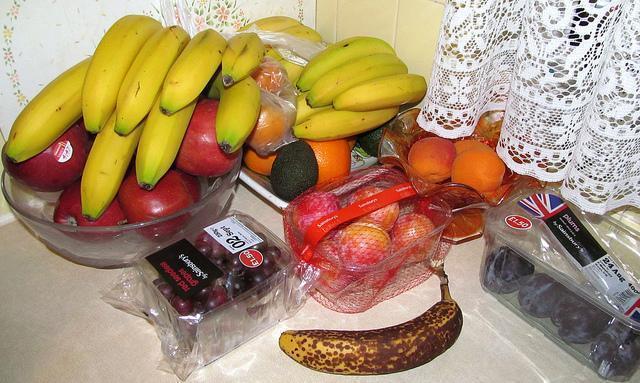What color is the banana without a bunch on the countertop directly?
Pick the correct solution from the four options below to address the question.
Options: Brown, black, yellow, green. Brown. 